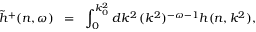Convert formula to latex. <formula><loc_0><loc_0><loc_500><loc_500>\tilde { h } ^ { + } ( n , \omega ) \, = \, \int _ { 0 } ^ { k _ { 0 } ^ { 2 } } d k ^ { 2 } \, ( k ^ { 2 } ) ^ { - \omega - 1 } h ( n , k ^ { 2 } ) ,</formula> 